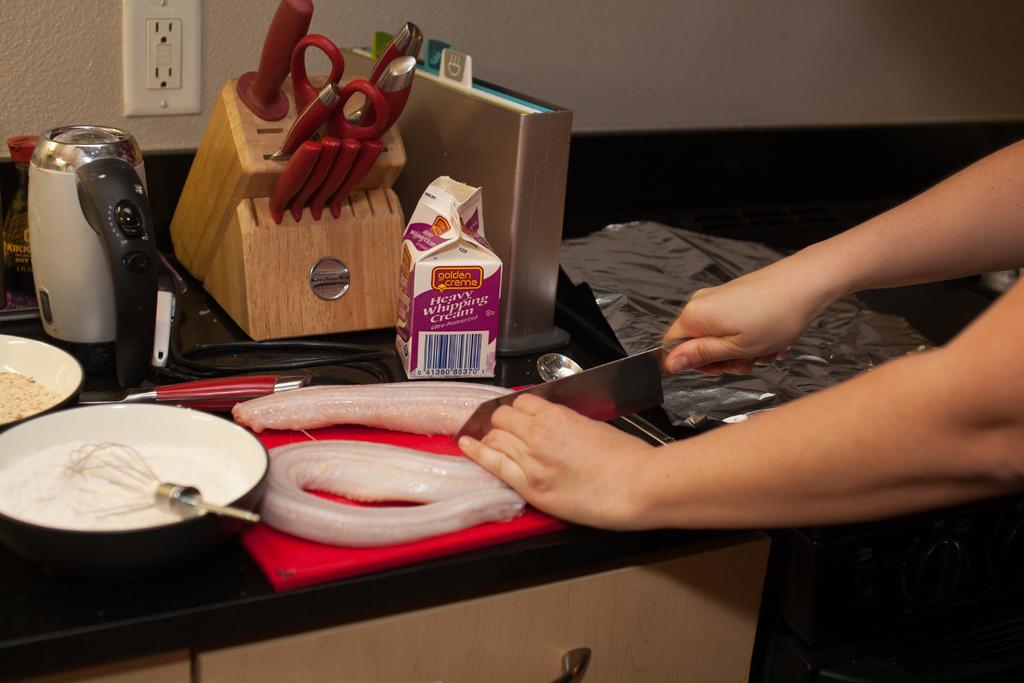What does the milk carton say?
Your answer should be compact. Heavy whipping cream. Is she using whipping cream to cook with?
Offer a terse response. Yes. 